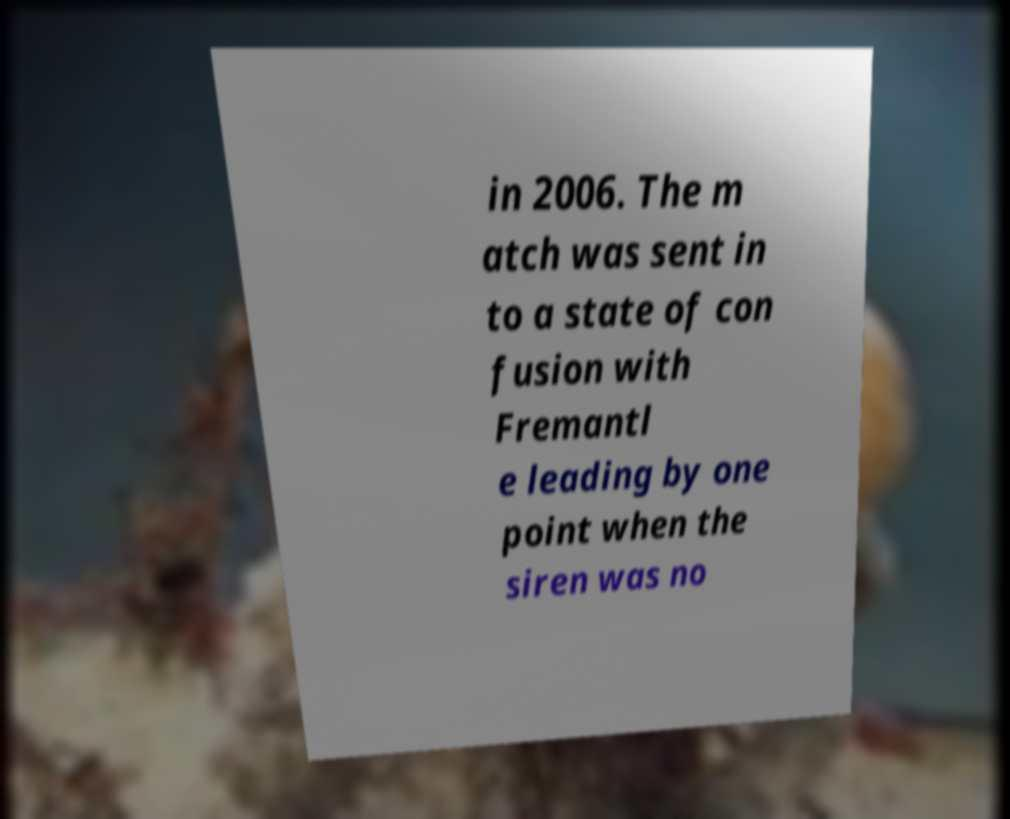Please read and relay the text visible in this image. What does it say? in 2006. The m atch was sent in to a state of con fusion with Fremantl e leading by one point when the siren was no 